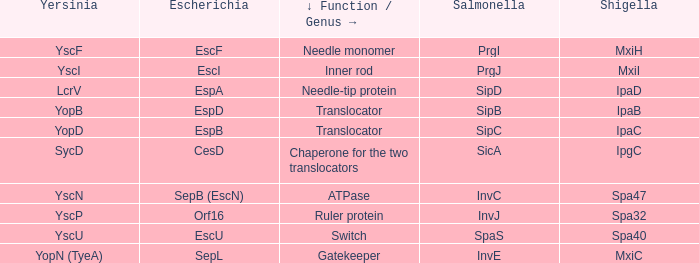Parse the full table. {'header': ['Yersinia', 'Escherichia', '↓ Function / Genus →', 'Salmonella', 'Shigella'], 'rows': [['YscF', 'EscF', 'Needle monomer', 'PrgI', 'MxiH'], ['YscI', 'EscI', 'Inner rod', 'PrgJ', 'MxiI'], ['LcrV', 'EspA', 'Needle-tip protein', 'SipD', 'IpaD'], ['YopB', 'EspD', 'Translocator', 'SipB', 'IpaB'], ['YopD', 'EspB', 'Translocator', 'SipC', 'IpaC'], ['SycD', 'CesD', 'Chaperone for the two translocators', 'SicA', 'IpgC'], ['YscN', 'SepB (EscN)', 'ATPase', 'InvC', 'Spa47'], ['YscP', 'Orf16', 'Ruler protein', 'InvJ', 'Spa32'], ['YscU', 'EscU', 'Switch', 'SpaS', 'Spa40'], ['YopN (TyeA)', 'SepL', 'Gatekeeper', 'InvE', 'MxiC']]} Could you explain the shigella counterpart for yersinia yopb? IpaB. 